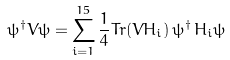<formula> <loc_0><loc_0><loc_500><loc_500>\psi ^ { \dagger } V \psi = \sum _ { i = 1 } ^ { 1 5 } \frac { 1 } { 4 } T r ( V H _ { i } ) \, \psi ^ { \dagger } \, H _ { i } \psi</formula> 